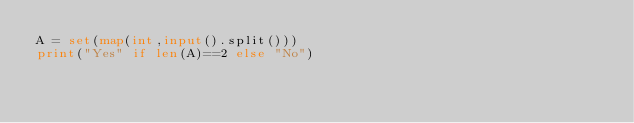<code> <loc_0><loc_0><loc_500><loc_500><_Python_>A = set(map(int,input().split()))
print("Yes" if len(A)==2 else "No")</code> 